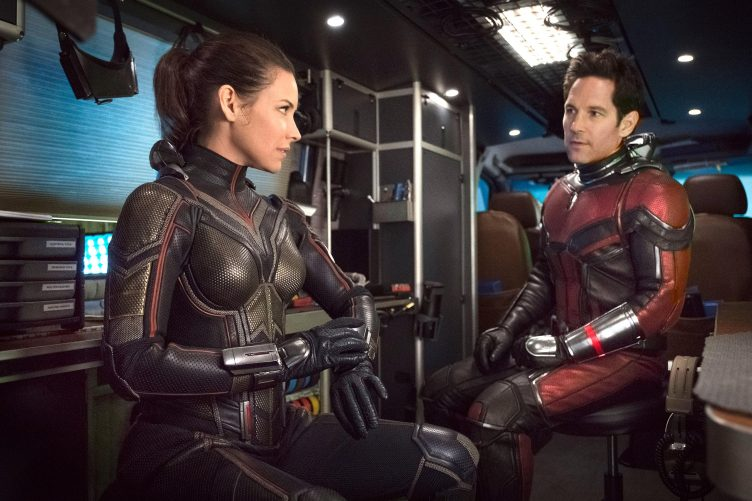What appears to be the relationship dynamic between these two characters in this scene? In this scene, the relationship dynamic between the two characters suggests a professional yet intimate collaboration. Their serious expressions and focused engagement imply they are discussing a significant plan or strategy, likely tackling a complex challenge in their adventure. Their body language, seated closely yet facing each other, underscores a mutual respect and dependence crucial for their partnership in the narrative. 